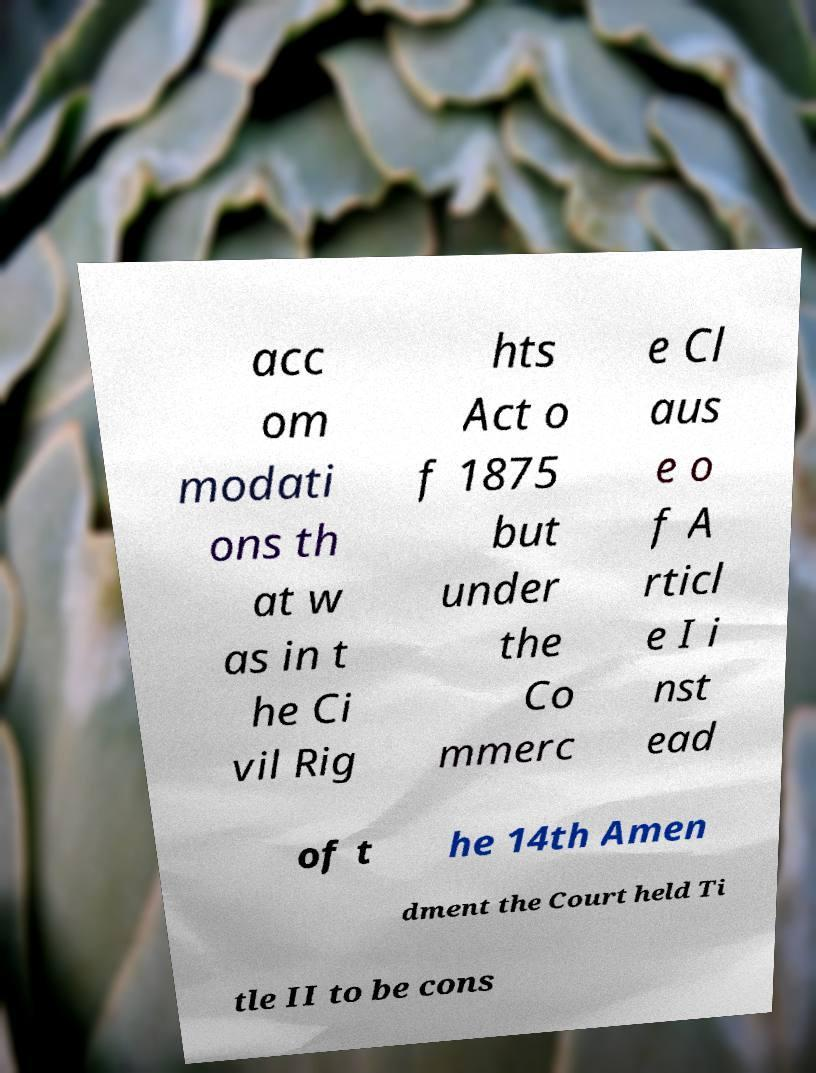There's text embedded in this image that I need extracted. Can you transcribe it verbatim? acc om modati ons th at w as in t he Ci vil Rig hts Act o f 1875 but under the Co mmerc e Cl aus e o f A rticl e I i nst ead of t he 14th Amen dment the Court held Ti tle II to be cons 